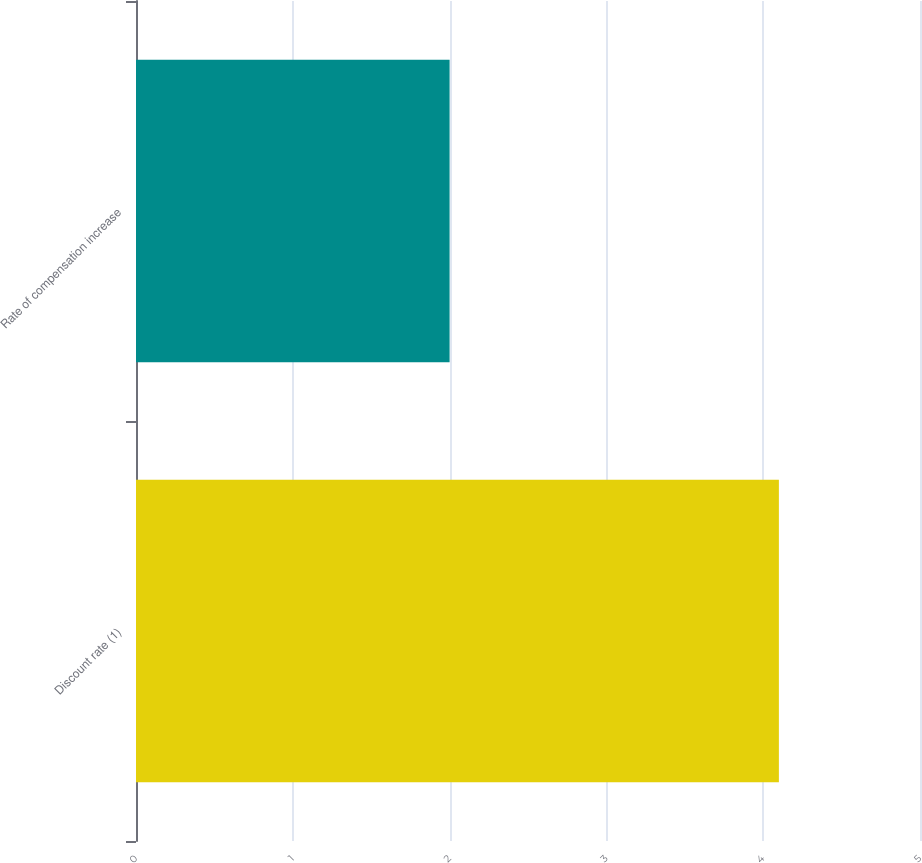<chart> <loc_0><loc_0><loc_500><loc_500><bar_chart><fcel>Discount rate (1)<fcel>Rate of compensation increase<nl><fcel>4.1<fcel>2<nl></chart> 